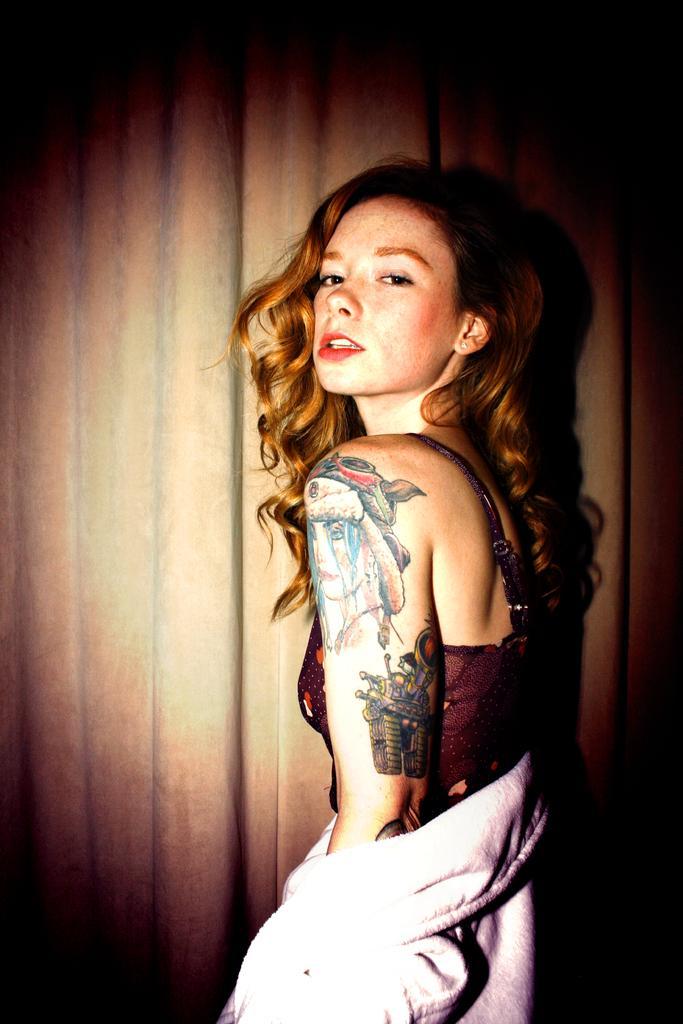Describe this image in one or two sentences. In this image I can see the person standing and the person is wearing white color dress and I can see the brown color background. 